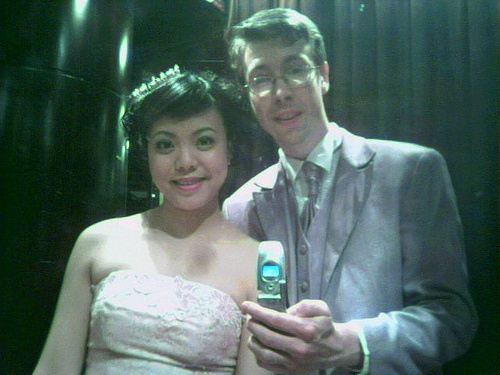Describe the objects in this image and their specific colors. I can see people in black, gray, darkgray, and purple tones, people in black, lightgray, darkgray, and gray tones, cell phone in black, white, teal, gray, and turquoise tones, and tie in black, gray, and darkgray tones in this image. 